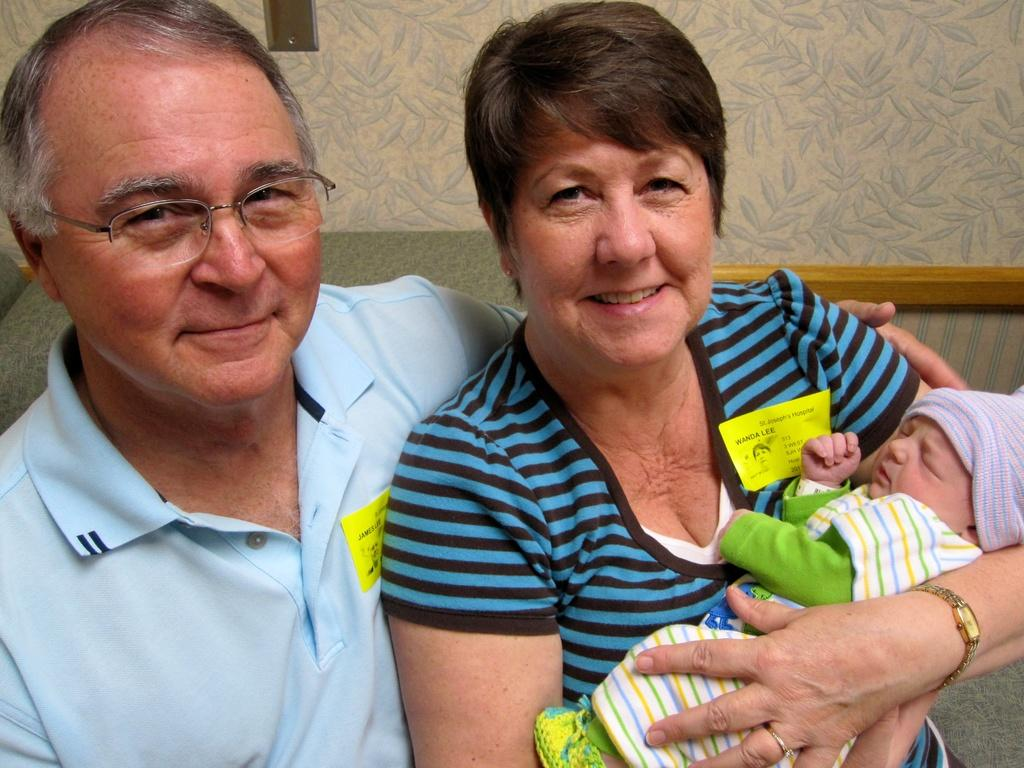How many people are sitting on the couch in the image? There are two people sitting on the couch in the image. What is the woman holding in the image? The woman is holding a baby in the image. What can be seen behind the people in the image? There is a wall behind the people in the image. What type of insect is crawling on the chairs in the image? There are no chairs or insects present in the image; it features two people sitting on a couch and a wall behind them. 